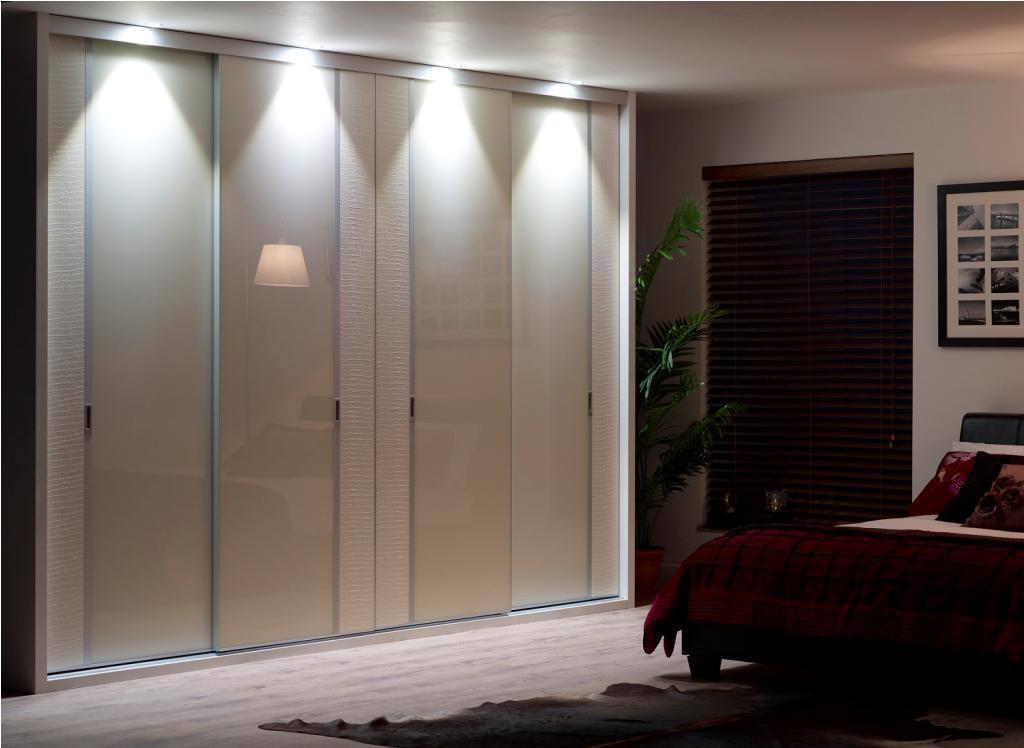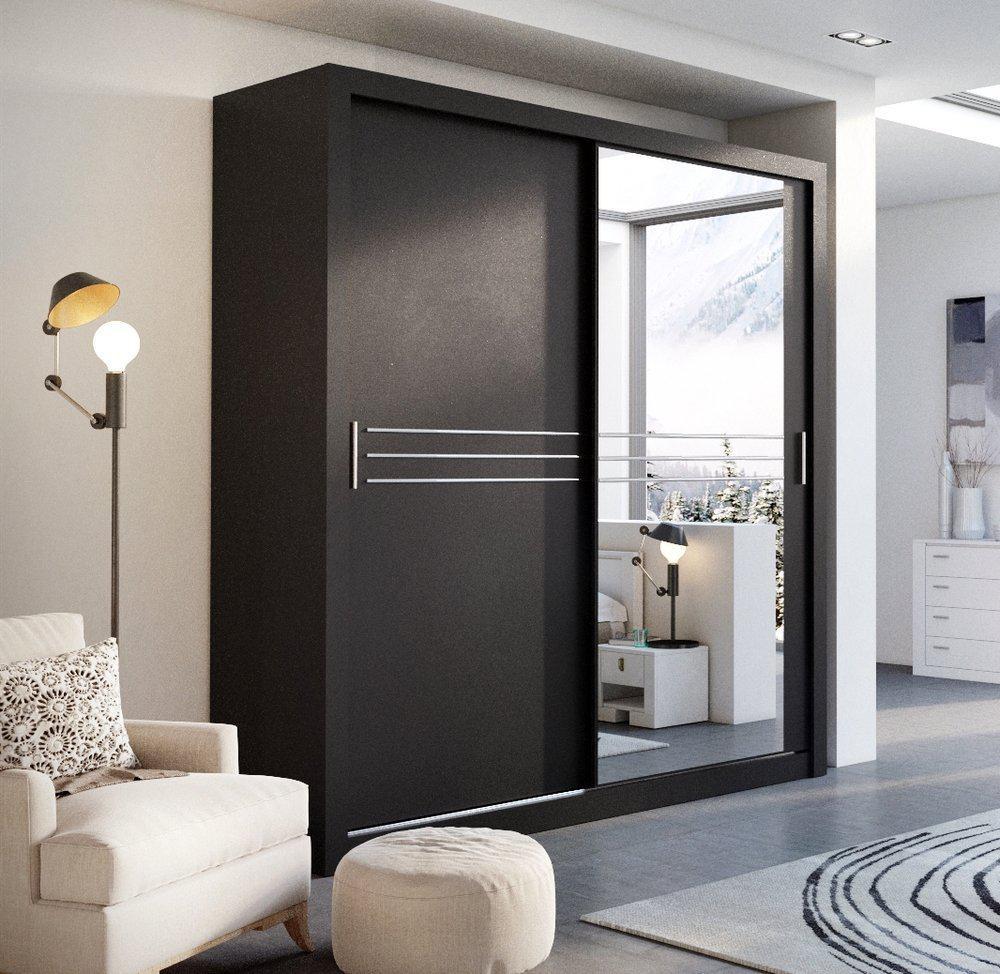The first image is the image on the left, the second image is the image on the right. Considering the images on both sides, is "An image shows a wardrobe with mirror on the right and black panel on the left." valid? Answer yes or no. Yes. 